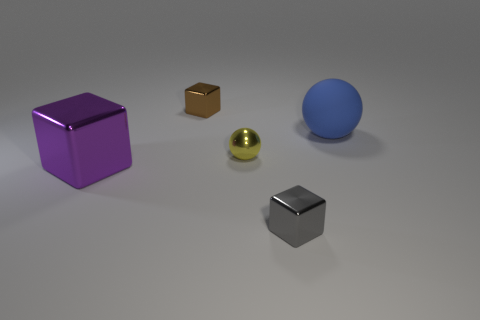Add 4 tiny cyan matte things. How many objects exist? 9 Subtract all cubes. How many objects are left? 2 Add 3 tiny cyan matte things. How many tiny cyan matte things exist? 3 Subtract 0 green spheres. How many objects are left? 5 Subtract all blue rubber things. Subtract all yellow rubber blocks. How many objects are left? 4 Add 4 small brown shiny blocks. How many small brown shiny blocks are left? 5 